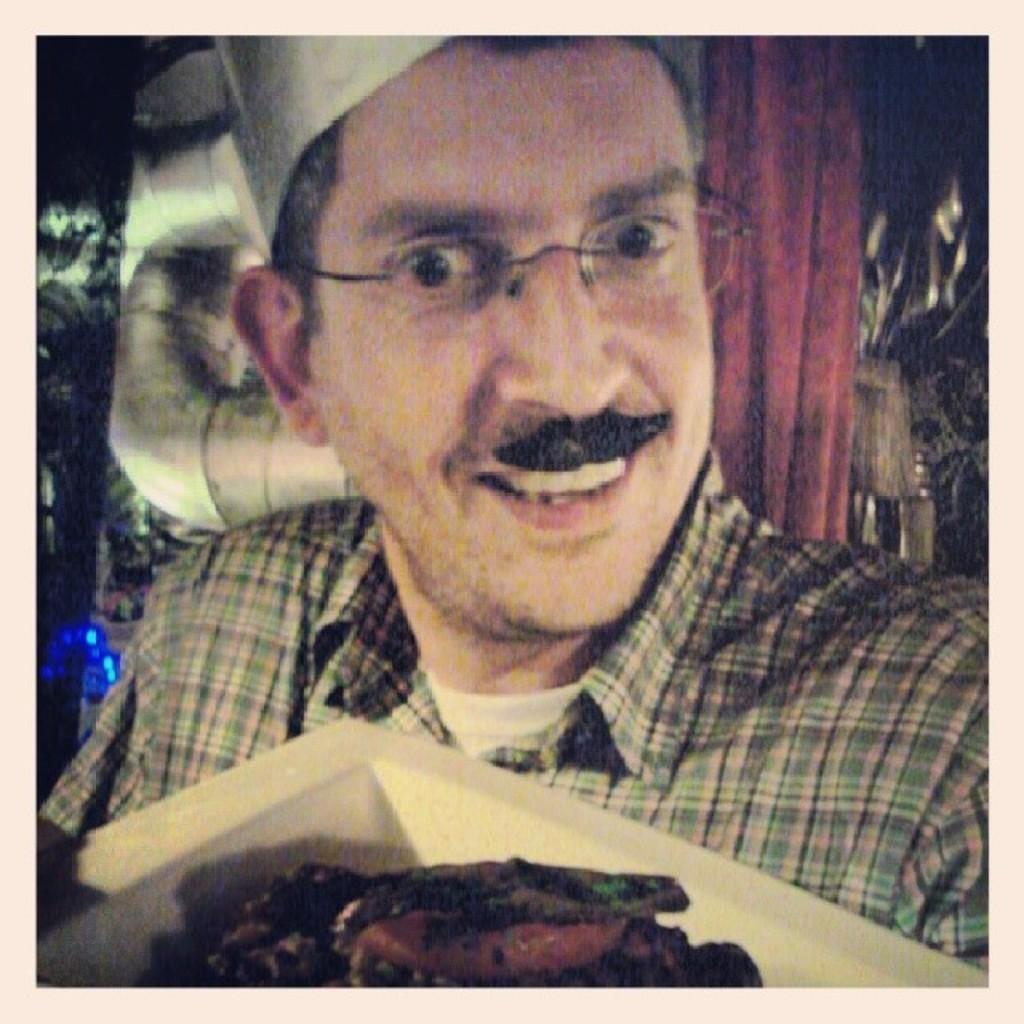Could you give a brief overview of what you see in this image? In the image a person is holding a plate, in the plate we can see some food. Behind the person we can see a wall. 